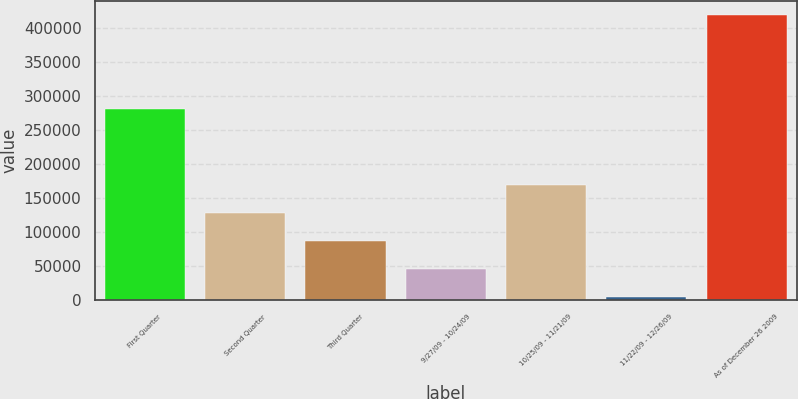Convert chart. <chart><loc_0><loc_0><loc_500><loc_500><bar_chart><fcel>First Quarter<fcel>Second Quarter<fcel>Third Quarter<fcel>9/27/09 - 10/24/09<fcel>10/25/09 - 11/21/09<fcel>11/22/09 - 12/26/09<fcel>As of December 26 2009<nl><fcel>280984<fcel>128860<fcel>87406.8<fcel>45953.4<fcel>170314<fcel>4500<fcel>419034<nl></chart> 